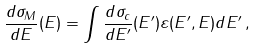Convert formula to latex. <formula><loc_0><loc_0><loc_500><loc_500>\frac { d \sigma _ { M } } { d E } ( E ) = \int \frac { d \sigma _ { c } } { d E ^ { \prime } } ( E ^ { \prime } ) \varepsilon ( E ^ { \prime } , E ) d E ^ { \prime } \, ,</formula> 